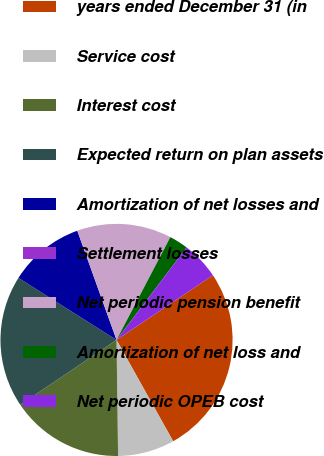Convert chart. <chart><loc_0><loc_0><loc_500><loc_500><pie_chart><fcel>years ended December 31 (in<fcel>Service cost<fcel>Interest cost<fcel>Expected return on plan assets<fcel>Amortization of net losses and<fcel>Settlement losses<fcel>Net periodic pension benefit<fcel>Amortization of net loss and<fcel>Net periodic OPEB cost<nl><fcel>26.3%<fcel>7.9%<fcel>15.78%<fcel>18.41%<fcel>10.53%<fcel>0.01%<fcel>13.16%<fcel>2.64%<fcel>5.27%<nl></chart> 